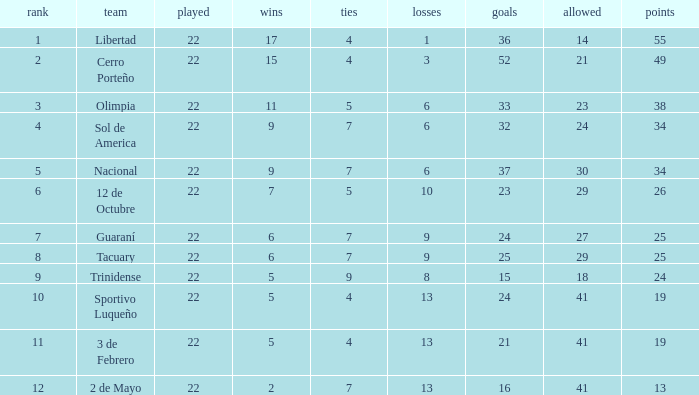What is the number of draws for the team with more than 8 losses and 13 points? 7.0. 